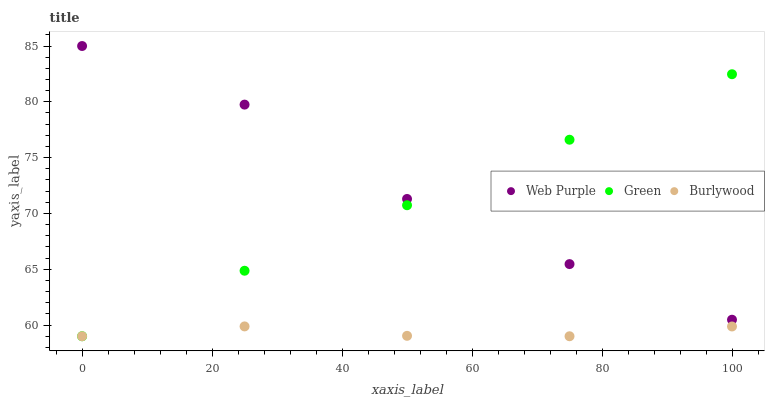Does Burlywood have the minimum area under the curve?
Answer yes or no. Yes. Does Web Purple have the maximum area under the curve?
Answer yes or no. Yes. Does Green have the minimum area under the curve?
Answer yes or no. No. Does Green have the maximum area under the curve?
Answer yes or no. No. Is Green the smoothest?
Answer yes or no. Yes. Is Web Purple the roughest?
Answer yes or no. Yes. Is Web Purple the smoothest?
Answer yes or no. No. Is Green the roughest?
Answer yes or no. No. Does Burlywood have the lowest value?
Answer yes or no. Yes. Does Web Purple have the lowest value?
Answer yes or no. No. Does Web Purple have the highest value?
Answer yes or no. Yes. Does Green have the highest value?
Answer yes or no. No. Is Burlywood less than Web Purple?
Answer yes or no. Yes. Is Web Purple greater than Burlywood?
Answer yes or no. Yes. Does Burlywood intersect Green?
Answer yes or no. Yes. Is Burlywood less than Green?
Answer yes or no. No. Is Burlywood greater than Green?
Answer yes or no. No. Does Burlywood intersect Web Purple?
Answer yes or no. No. 